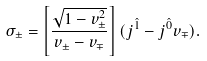<formula> <loc_0><loc_0><loc_500><loc_500>\sigma _ { \pm } = \left [ \frac { \sqrt { 1 - v ^ { 2 } _ { \pm } } } { v _ { \pm } - v _ { \mp } } \right ] ( \sl j ^ { \hat { 1 } } - \sl j ^ { \hat { 0 } } v _ { \mp } ) .</formula> 